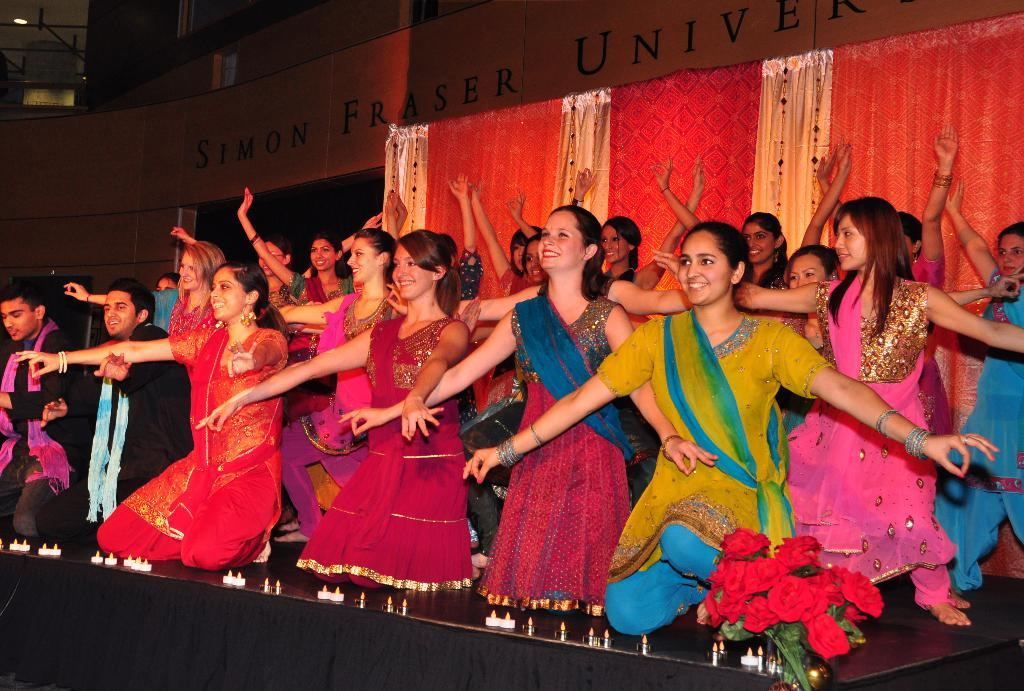What are the performers on the stage doing? The performers on the stage are girls and boys who are performing. What is located behind the performers on the stage? There is a curtain behind the performers. What can be seen in the background of the image? There is a building in the background of the image. What type of cap is the quince wearing in the image? There is no quince or cap present in the image. Where is the bedroom located in the image? There is no bedroom present in the image. 